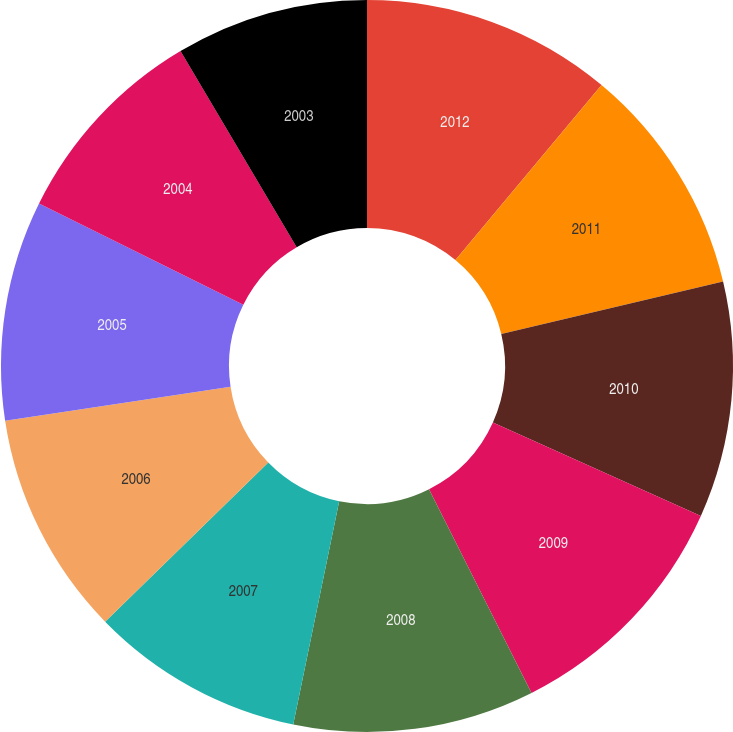<chart> <loc_0><loc_0><loc_500><loc_500><pie_chart><fcel>2012<fcel>2011<fcel>2010<fcel>2009<fcel>2008<fcel>2007<fcel>2006<fcel>2005<fcel>2004<fcel>2003<nl><fcel>11.07%<fcel>10.22%<fcel>10.43%<fcel>10.86%<fcel>10.65%<fcel>9.46%<fcel>9.92%<fcel>9.71%<fcel>9.17%<fcel>8.51%<nl></chart> 